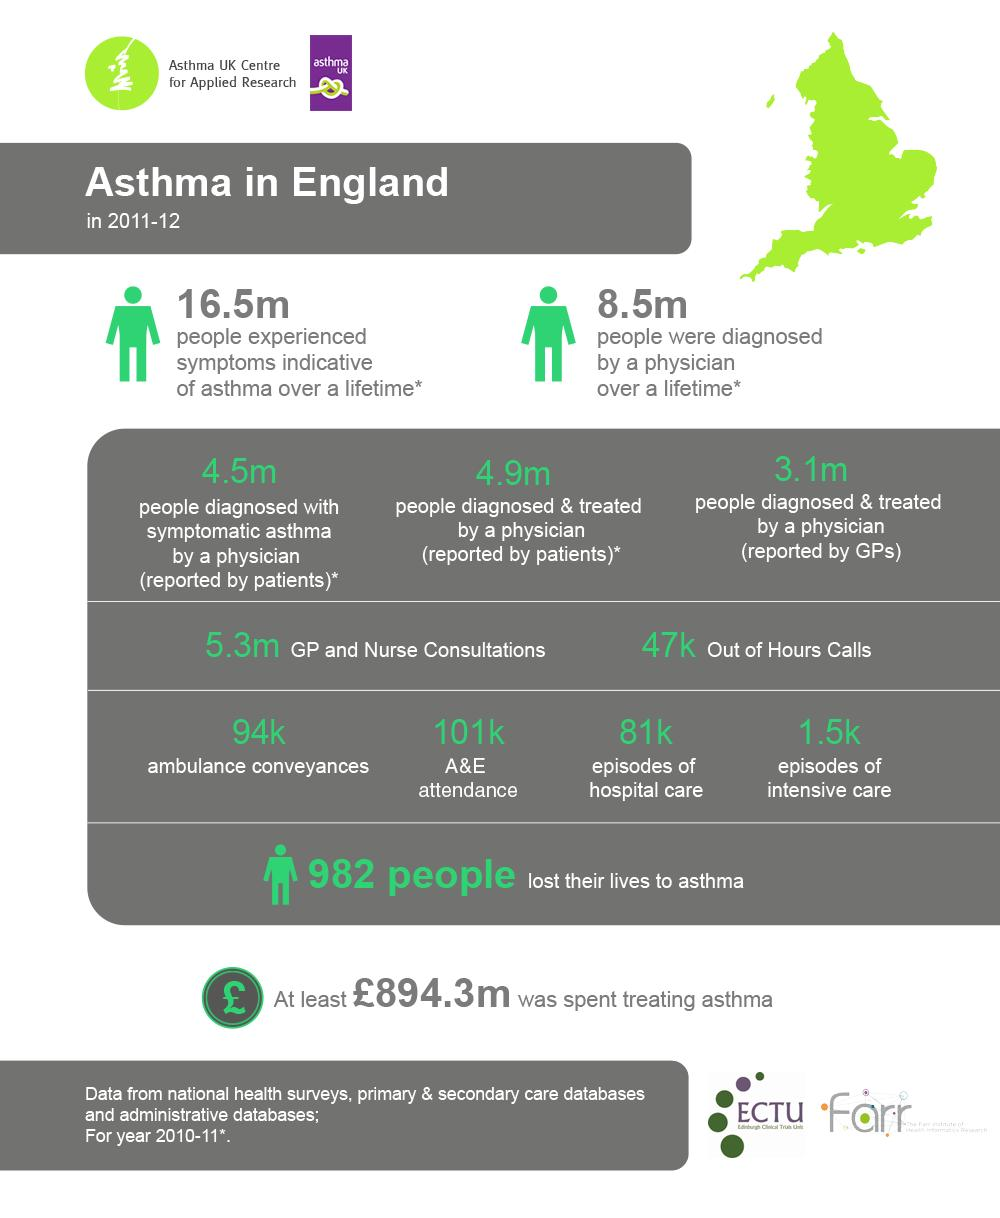Specify some key components in this picture. The difference between the numbers reported by patients and general practitioners (GPs) is 1.8 million. 